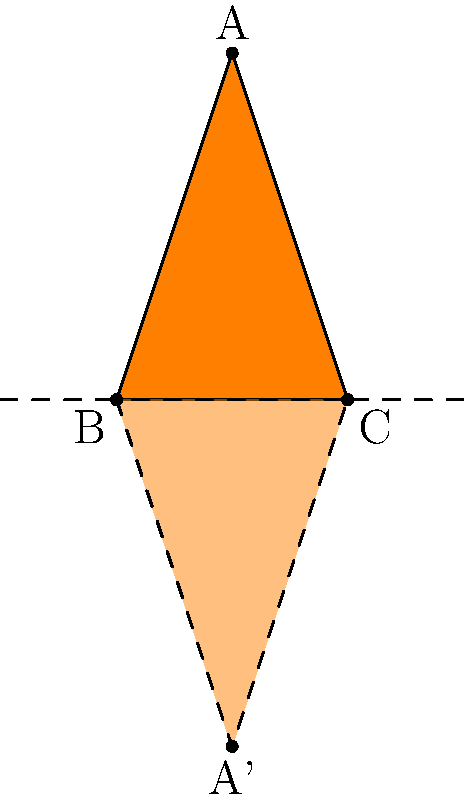A carrot-shaped polygon ABC is reflected across the x-axis. If point A has coordinates (1, 3), what are the coordinates of its reflection, point A'? To find the coordinates of point A' after reflecting point A across the x-axis, we follow these steps:

1. Identify the original coordinates of point A: (1, 3)

2. Understand the reflection rule across the x-axis:
   - The x-coordinate remains the same
   - The y-coordinate changes sign (becomes negative)

3. Apply the reflection rule to point A:
   - x-coordinate: 1 (unchanged)
   - y-coordinate: -3 (sign changed from positive to negative)

4. Combine the new coordinates:
   A' = (1, -3)

This reflection creates a mirror image of the carrot shape below the x-axis, with point A' being the reflection of point A.
Answer: (1, -3) 